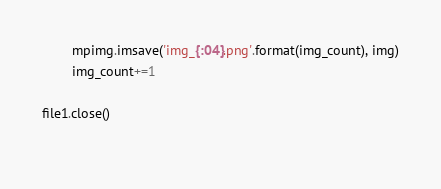<code> <loc_0><loc_0><loc_500><loc_500><_Python_>        mpimg.imsave('img_{:04}.png'.format(img_count), img)
        img_count+=1

file1.close()
    </code> 